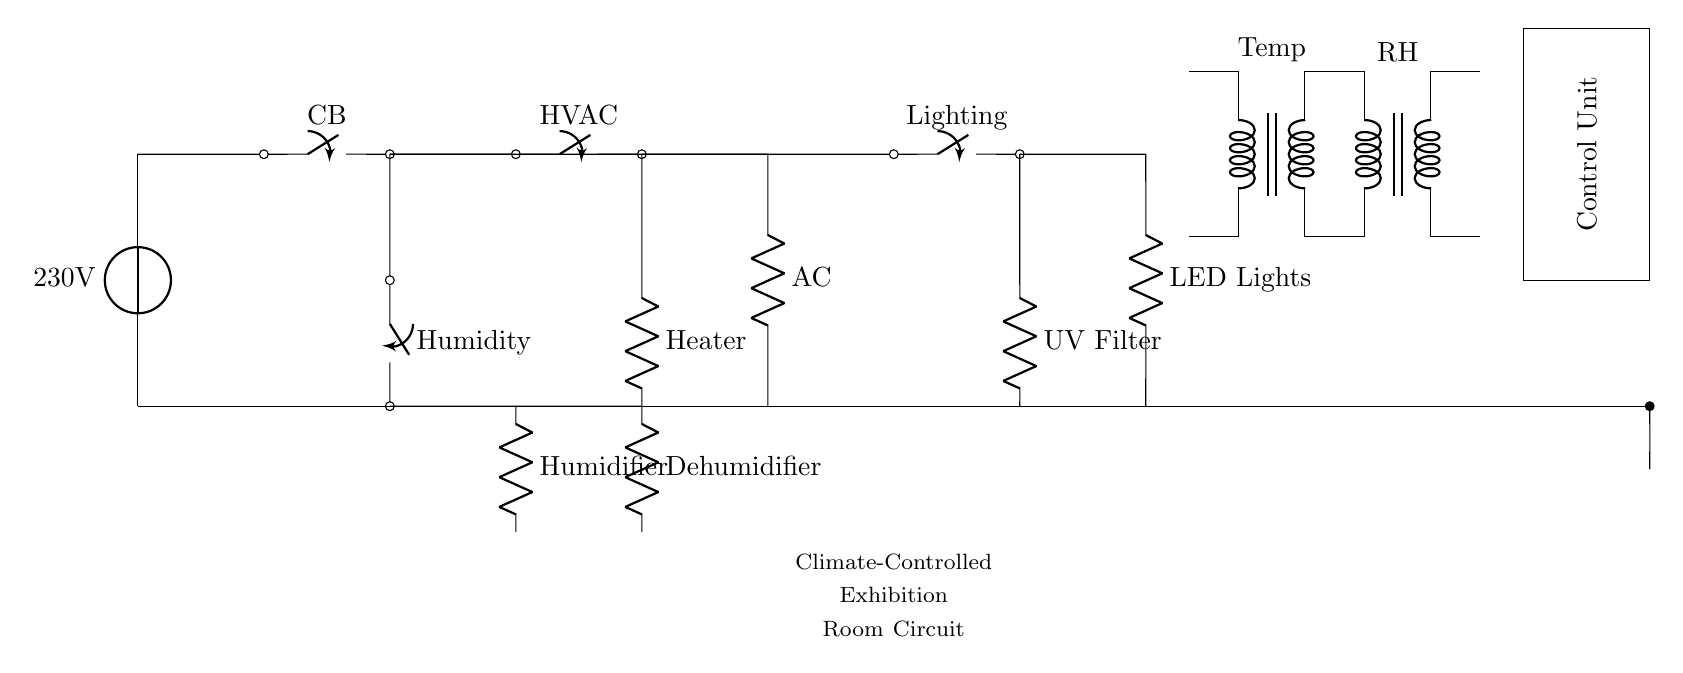What is the main voltage supply for this circuit? The circuit is supplied by a voltage source labeled as 230V. This indicates the standard electrical supply used in the circuit for powering various components. The voltage source is the first element in the circuit at the top, clearly showing the voltage value.
Answer: 230V What component controls humidity in this circuit? The circuit has a component labeled as "Humidity" which is a closing switch that links to the humidifier and dehumidifier. This component is identified by its specific label in the diagram, and its connections further illustrate its role in maintaining humidity levels in the exhibition room.
Answer: Humidity Which appliance is labeled as a UV filter? The circuit diagram shows a component labeled as "UV Filter," located in the section where lighting control takes place. Its role is to filter ultraviolet light, which can be harmful to ancient artifacts, preventing degradation while allowing sufficient illumination. This component is clearly indicated in the lighting section.
Answer: UV Filter What does the control unit regulate in this circuit? The control unit regulates the operations of various components of the circuit based on input from sensors. This unit is tasked with managing the HVAC system, humidity controls, and lighting to maintain conditions suitable for preserving ancient artifacts. Its placement in the diagram signifies its overarching role in circuit control.
Answer: HVAC, Humidity, Lighting What is the connection type for the heater and air conditioning unit? Both the heater and air conditioning unit are connected in parallel to the power source. This means they can operate independently of each other, allowing for effective climate control in the exhibition room without one affecting the other’s operation. The visual representation shows their separate pathways from the HVAC control switch.
Answer: Parallel 